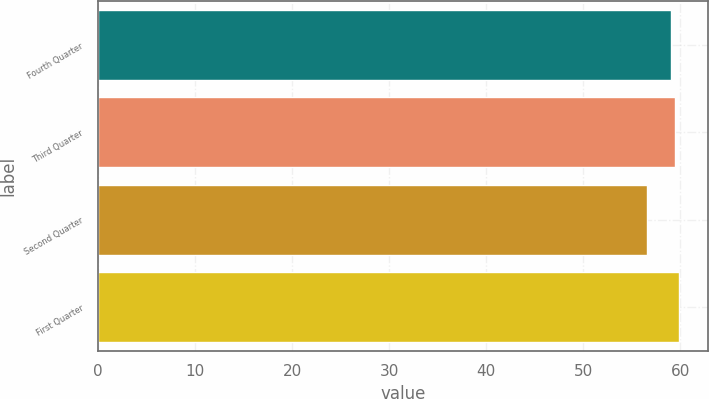Convert chart. <chart><loc_0><loc_0><loc_500><loc_500><bar_chart><fcel>Fourth Quarter<fcel>Third Quarter<fcel>Second Quarter<fcel>First Quarter<nl><fcel>59.07<fcel>59.42<fcel>56.55<fcel>59.87<nl></chart> 